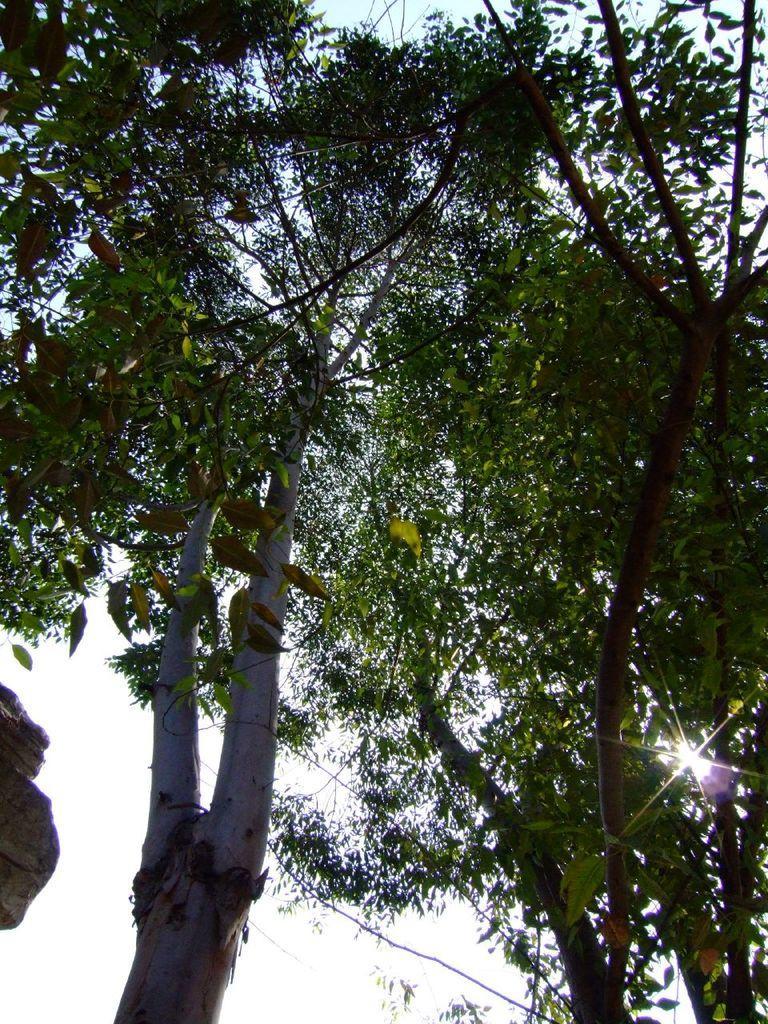Can you describe this image briefly? The picture consists of trees and sky. On the right it is sun shining in the sky. 